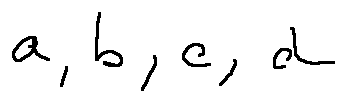Convert formula to latex. <formula><loc_0><loc_0><loc_500><loc_500>a , b , c , d</formula> 